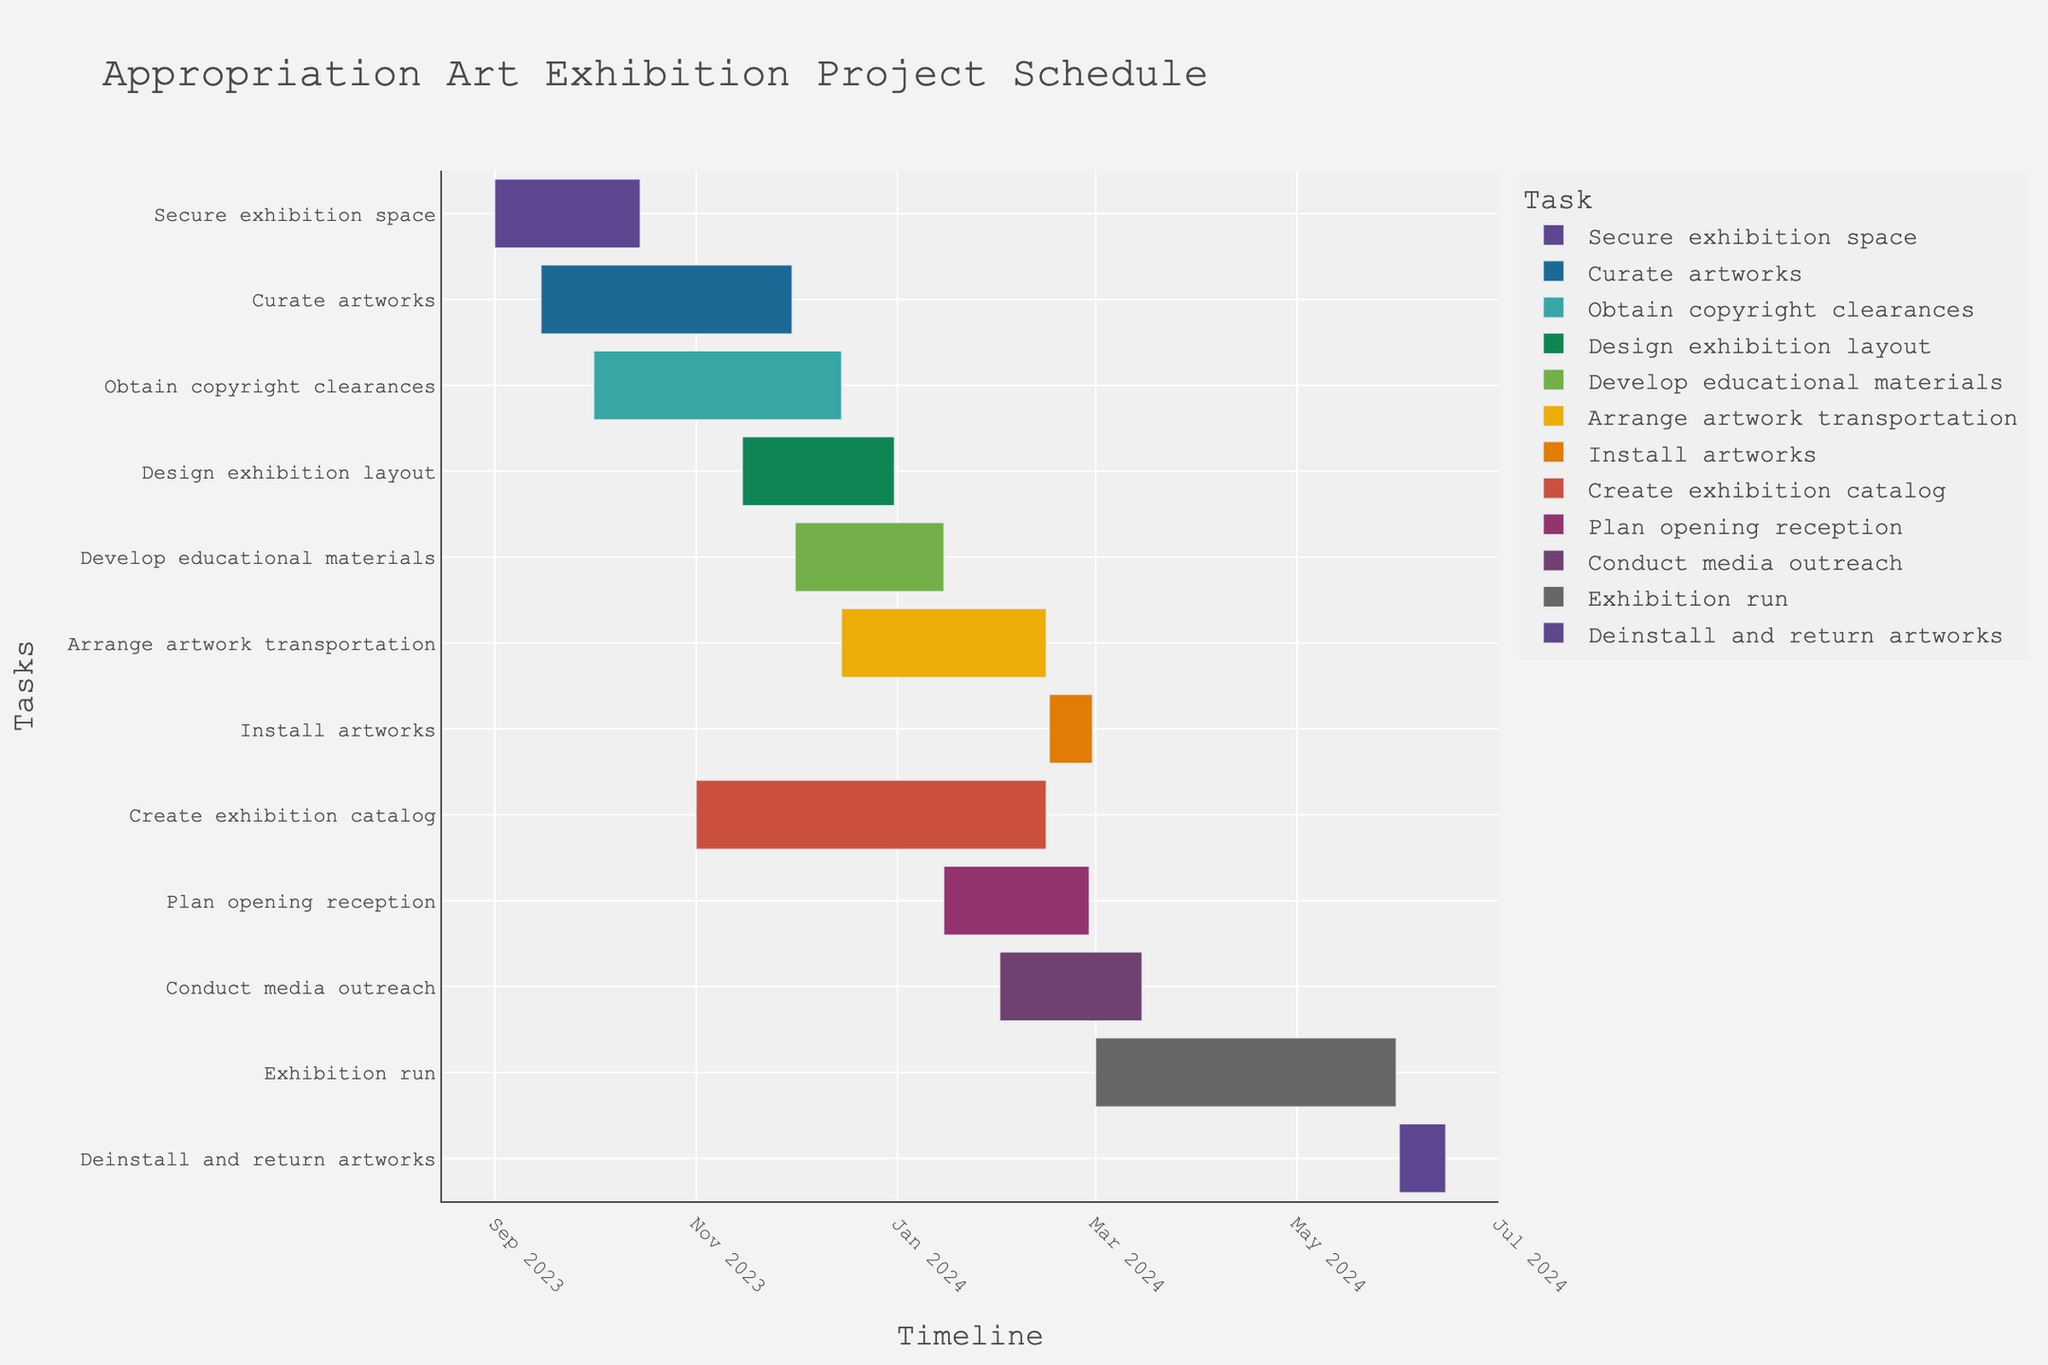What's the title of the Gantt chart? The title is typically found at the top of the chart, usually in a larger and bolder font.
Answer: Appropriation Art Exhibition Project Schedule What is the duration of the Curate artworks task? The duration of each task is listed in the data; the Curate artworks task has a duration column of 76 days.
Answer: 76 days Which task has the longest duration? By comparing the duration of each task, the Create exhibition catalog task has the longest duration of 106 days.
Answer: Create exhibition catalog During which months does the Obtain copyright clearances task occur? The start and end dates for Obtain copyright clearances are shown on the timeline; it starts in October 2023 and ends in December 2023.
Answer: October 2023 to December 2023 How many tasks are scheduled during February 2024? Observing the tasks’ timelines, Create exhibition catalog, Install artworks, and Conduct media outreach tasks occur in February 2024.
Answer: Three tasks Which task ends last? The Gantt chart visually represents the end dates; the Deinstall and return artworks task ends on June 15, 2024, which is the latest.
Answer: Deinstall and return artworks What's the duration of the Exhibition run, and how does it compare to the Plan opening reception? The Exhibition run task has a duration of 92 days, while the Plan opening reception has a duration of 44 days. To compare, 92 days - 44 days = 48 days longer.
Answer: 48 days longer Which tasks overlap with the Develop educational materials task? Develop educational materials runs from December 1, 2023, to January 15, 2024. Overlapping tasks are Create exhibition catalog and Arrange artwork transportation.
Answer: Create exhibition catalog, Arrange artwork transportation What tasks are scheduled to start before November 2023? By checking the start dates in the timeline, Secure exhibition space, Curate artworks, and Obtain copyright clearances start before November 2023.
Answer: Secure exhibition space, Curate artworks, Obtain copyright clearances 